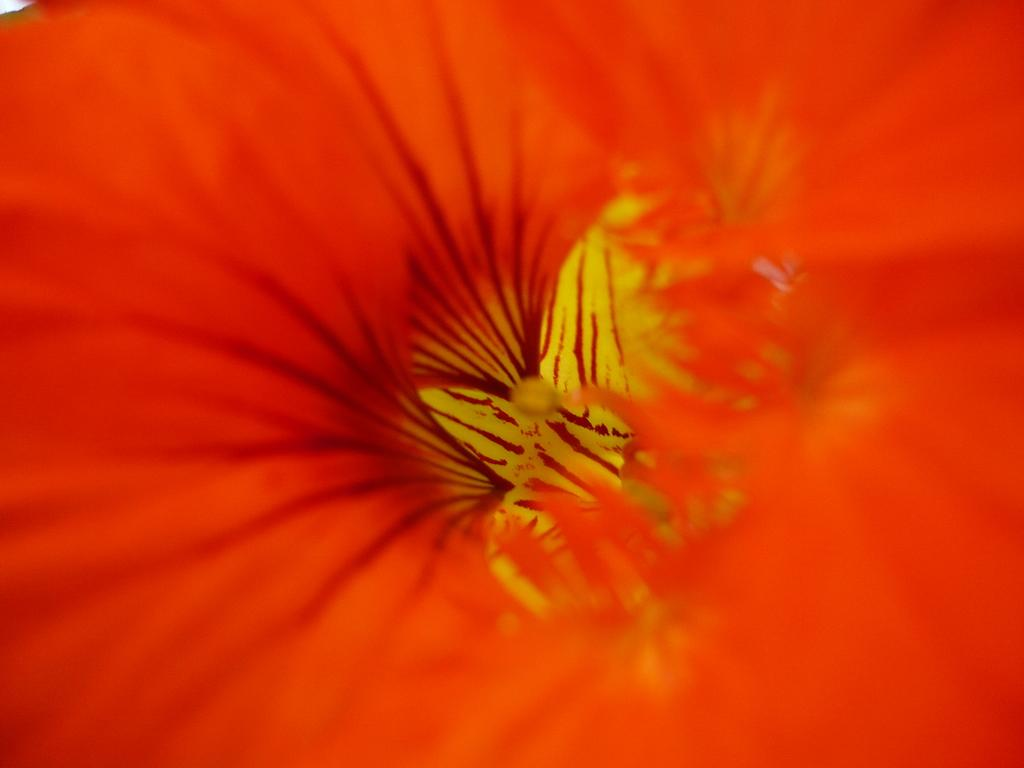What is the main subject of the image? There is a flower in the image. What color is the flower? The flower is red in color. What type of reaction does the secretary have when the plate breaks in the image? There is no plate or secretary present in the image, so it is not possible to determine any reactions. 